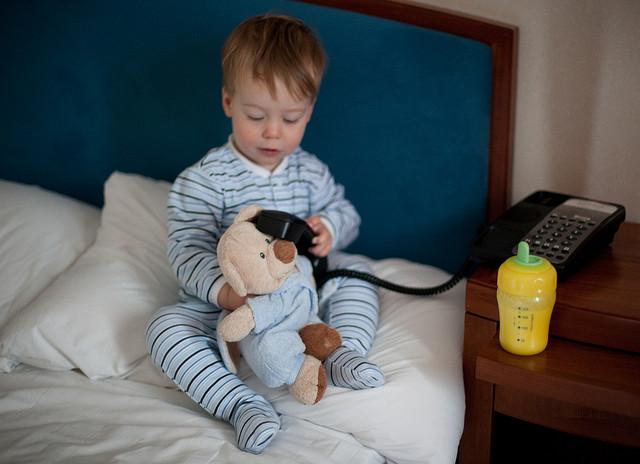Is the kid sitting on the bed?
Give a very brief answer. Yes. What is the kid holding to the bear?
Concise answer only. Phone. What color is the kid's cup?
Answer briefly. Yellow. 